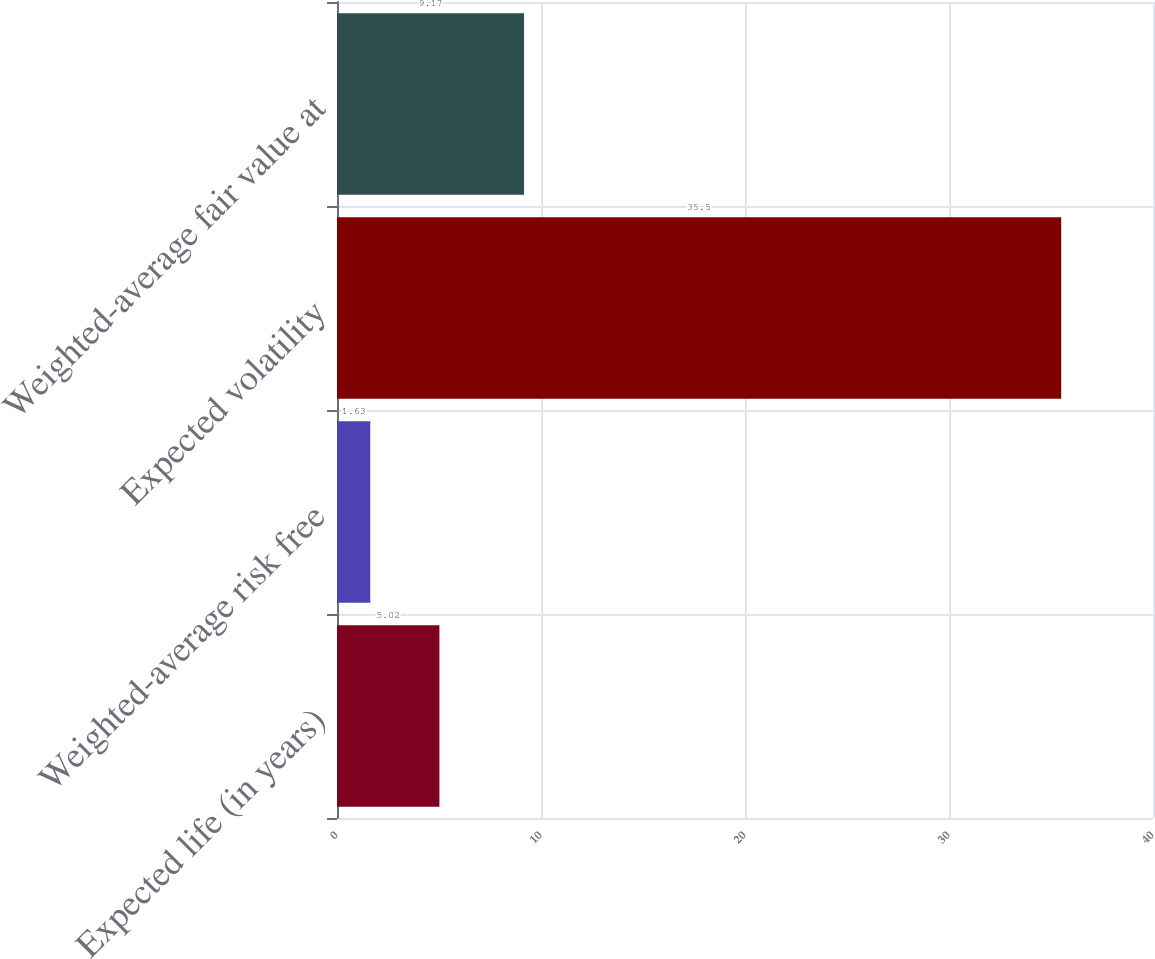Convert chart to OTSL. <chart><loc_0><loc_0><loc_500><loc_500><bar_chart><fcel>Expected life (in years)<fcel>Weighted-average risk free<fcel>Expected volatility<fcel>Weighted-average fair value at<nl><fcel>5.02<fcel>1.63<fcel>35.5<fcel>9.17<nl></chart> 